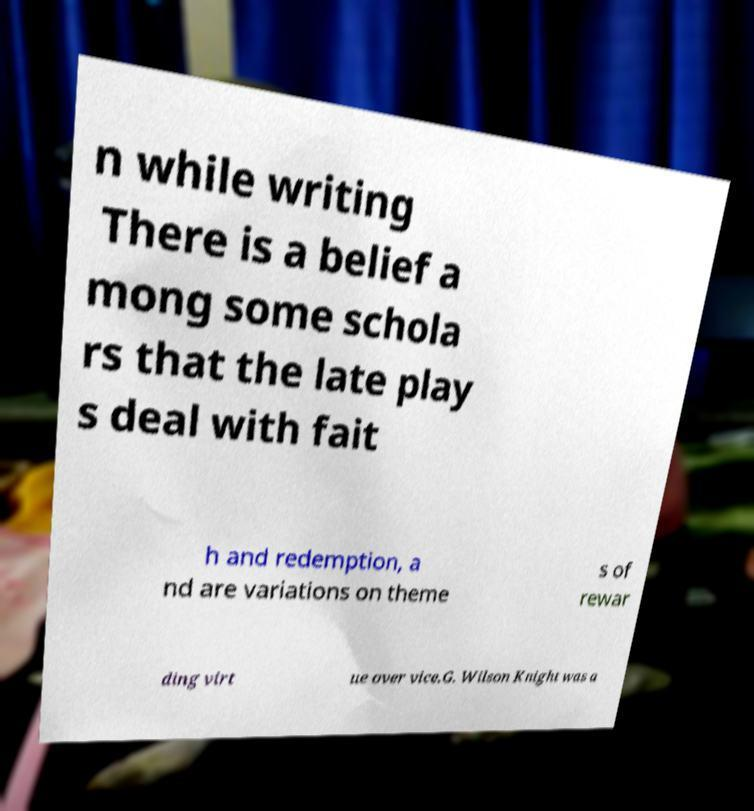Can you read and provide the text displayed in the image?This photo seems to have some interesting text. Can you extract and type it out for me? n while writing There is a belief a mong some schola rs that the late play s deal with fait h and redemption, a nd are variations on theme s of rewar ding virt ue over vice.G. Wilson Knight was a 